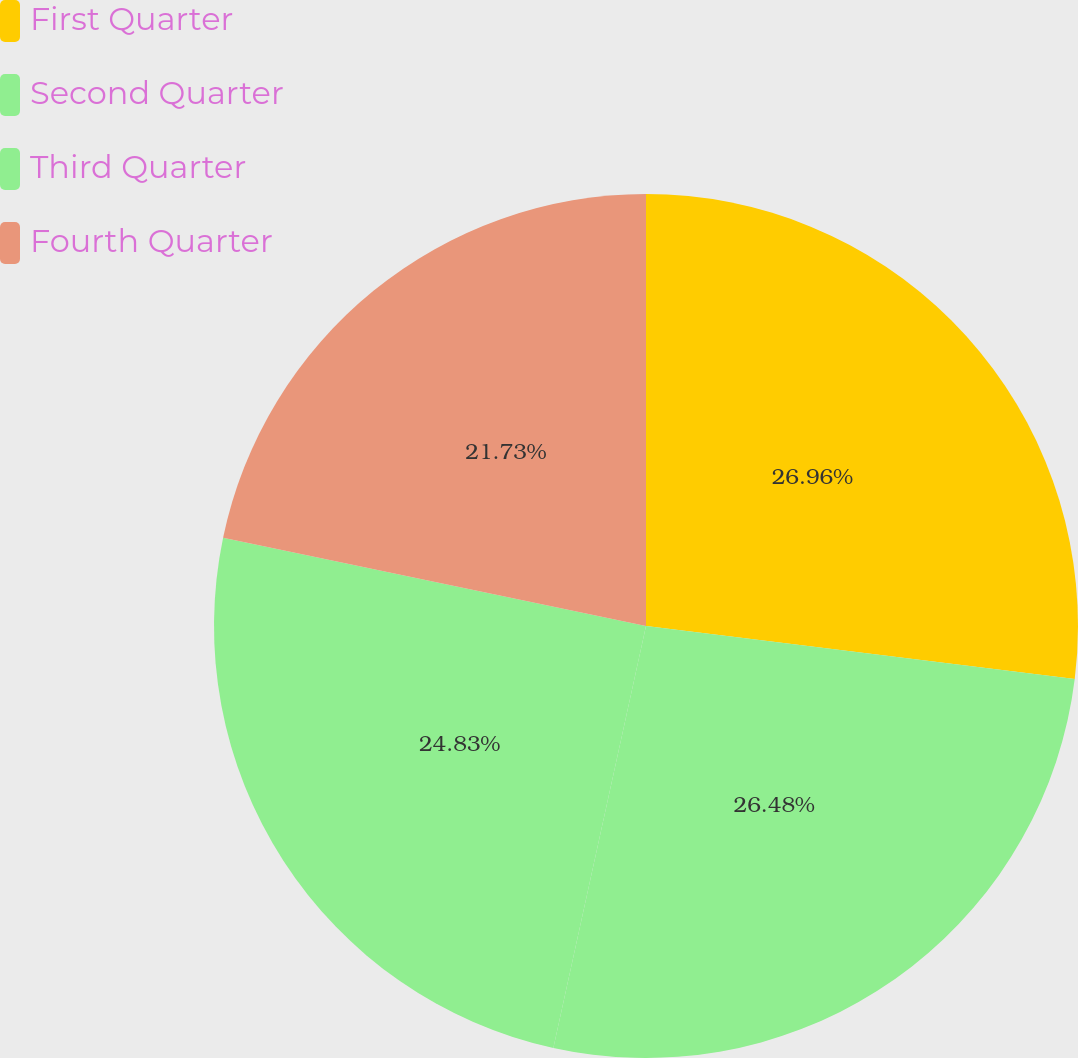Convert chart to OTSL. <chart><loc_0><loc_0><loc_500><loc_500><pie_chart><fcel>First Quarter<fcel>Second Quarter<fcel>Third Quarter<fcel>Fourth Quarter<nl><fcel>26.96%<fcel>26.48%<fcel>24.83%<fcel>21.73%<nl></chart> 